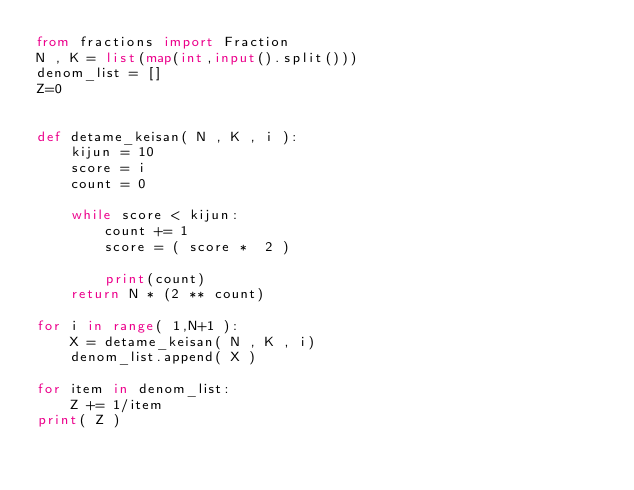<code> <loc_0><loc_0><loc_500><loc_500><_Python_>from fractions import Fraction
N , K = list(map(int,input().split()))
denom_list = []
Z=0


def detame_keisan( N , K , i ):
    kijun = 10
    score = i
    count = 0
    
    while score < kijun:
        count += 1
        score = ( score *  2 )
        
        print(count)
    return N * (2 ** count)

for i in range( 1,N+1 ):
    X = detame_keisan( N , K , i)
    denom_list.append( X )

for item in denom_list:
    Z += 1/item
print( Z )</code> 